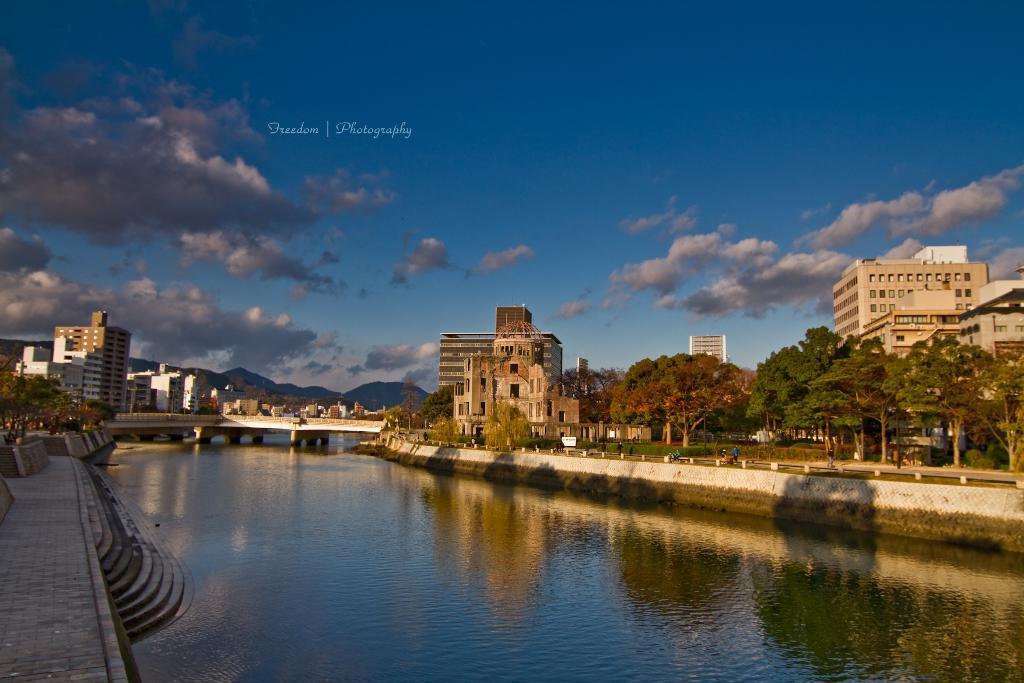In one or two sentences, can you explain what this image depicts? In this picture we can see the water, bridge, walls, steps, trees, buildings, mountains, some objects, some people and in the background we can see the sky with clouds. 